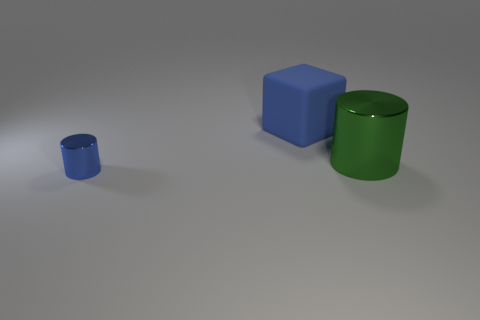Are there any other things that have the same size as the blue metal cylinder?
Your response must be concise. No. What is the size of the other cylinder that is the same material as the blue cylinder?
Provide a short and direct response. Large. What number of blocks have the same color as the tiny metallic object?
Offer a terse response. 1. Are there fewer shiny cylinders that are on the left side of the green thing than big objects that are behind the small blue cylinder?
Ensure brevity in your answer.  Yes. There is a shiny thing left of the large green metal thing; is it the same shape as the large green object?
Provide a succinct answer. Yes. Is there anything else that has the same material as the blue cube?
Give a very brief answer. No. Are the blue thing right of the small thing and the large green cylinder made of the same material?
Make the answer very short. No. What material is the object that is in front of the cylinder behind the cylinder in front of the large green object?
Provide a succinct answer. Metal. How many other objects are there of the same shape as the rubber object?
Offer a very short reply. 0. What is the color of the large object to the right of the large blue object?
Give a very brief answer. Green. 